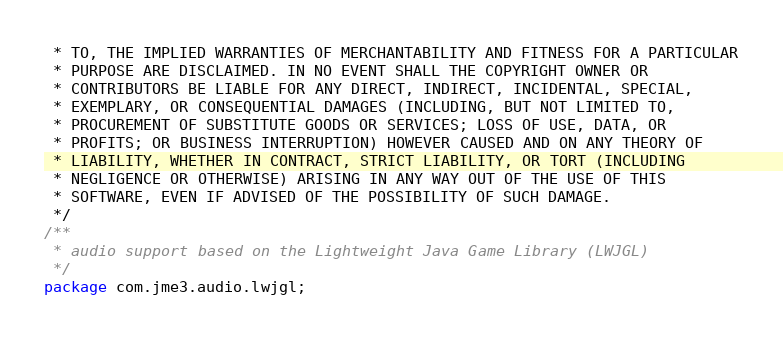Convert code to text. <code><loc_0><loc_0><loc_500><loc_500><_Java_> * TO, THE IMPLIED WARRANTIES OF MERCHANTABILITY AND FITNESS FOR A PARTICULAR
 * PURPOSE ARE DISCLAIMED. IN NO EVENT SHALL THE COPYRIGHT OWNER OR
 * CONTRIBUTORS BE LIABLE FOR ANY DIRECT, INDIRECT, INCIDENTAL, SPECIAL,
 * EXEMPLARY, OR CONSEQUENTIAL DAMAGES (INCLUDING, BUT NOT LIMITED TO,
 * PROCUREMENT OF SUBSTITUTE GOODS OR SERVICES; LOSS OF USE, DATA, OR
 * PROFITS; OR BUSINESS INTERRUPTION) HOWEVER CAUSED AND ON ANY THEORY OF
 * LIABILITY, WHETHER IN CONTRACT, STRICT LIABILITY, OR TORT (INCLUDING
 * NEGLIGENCE OR OTHERWISE) ARISING IN ANY WAY OUT OF THE USE OF THIS
 * SOFTWARE, EVEN IF ADVISED OF THE POSSIBILITY OF SUCH DAMAGE.
 */
/**
 * audio support based on the Lightweight Java Game Library (LWJGL)
 */
package com.jme3.audio.lwjgl;
</code> 